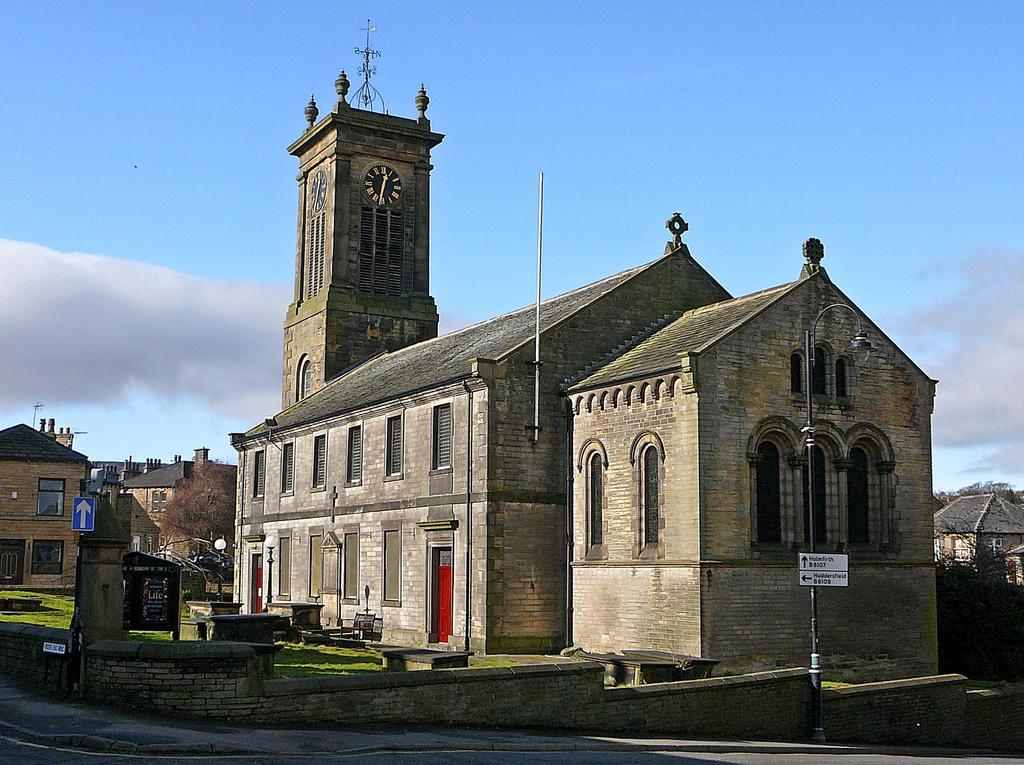Describe this image in one or two sentences. In this image we can see the clock tower, buildings, poles, grass and in the background we can see the sky. 